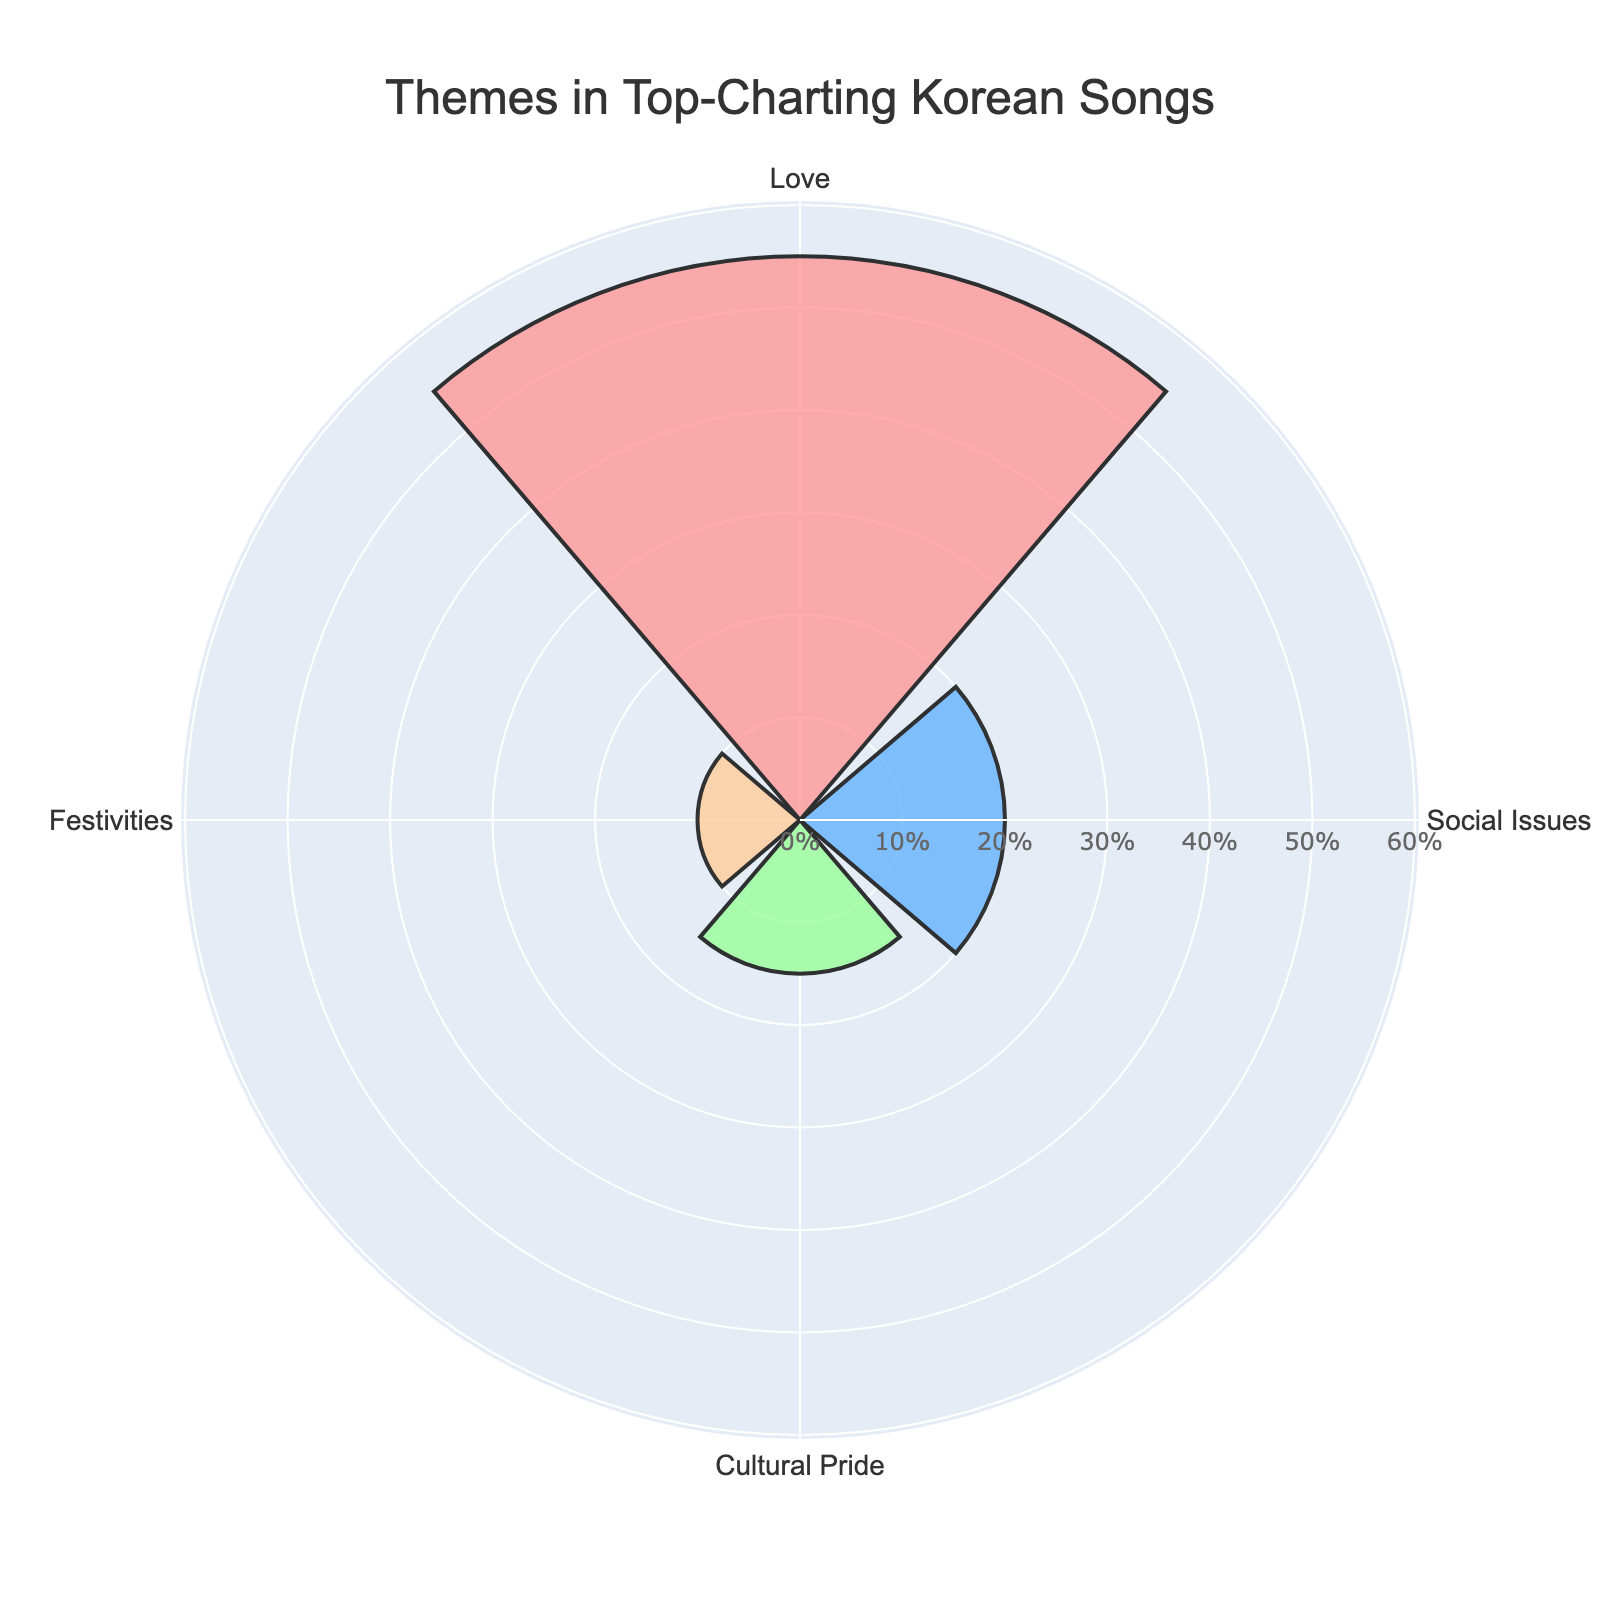Which theme appears most frequently in top-charting Korean songs? The theme with the highest proportion in the rose chart is the one that appears most frequently. From the chart, 'Love' has the largest segment.
Answer: Love What is the proportion of songs discussing social issues? The proportion is directly taken from the segment labeled 'Social Issues'.
Answer: 20% How much smaller is the proportion of 'Cultural Pride' compared to 'Love'? Subtract the proportion of 'Cultural Pride' from that of 'Love': 55 - 15 = 40
Answer: 40% What is the combined proportion of 'Festivities' and 'Social Issues'? Add the proportions of 'Festivities' and 'Social Issues': 10 + 20 = 30%
Answer: 30% Which theme has the smallest proportion in the chart? The theme with the smallest segment in the chart is 'Festivities'.
Answer: Festivities How does the proportion of 'Cultural Pride' compare to 'Social Issues'? Compare the proportions: 'Cultural Pride' is 15%, and 'Social Issues' is 20%. Thus, 'Cultural Pride' is less than 'Social Issues'.
Answer: Cultural Pride is less than Social Issues If the proportions of 'Love' and 'Cultural Pride' were combined, would they account for more than 70%? Add the proportions of 'Love' and 'Cultural Pride': 55 + 15 = 70%. Since it is equal to 70%, it does not exceed 70%.
Answer: No What is the average proportion of all themes in the chart? Sum all proportions and divide by the number of themes: (55 + 20 + 15 + 10) / 4 = 25%
Answer: 25% If 'Festivities' and 'Cultural Pride' themes doubled their proportions, what would be their new values? Double each proportion: Festivities: 10 * 2 = 20%, Cultural Pride: 15 * 2 = 30%
Answer: Festivities: 20%, Cultural Pride: 30% What theme would rank second in frequency based on the chart? Excluding the highest proportion (Love), the next highest value is 'Social Issues'.
Answer: Social Issues 